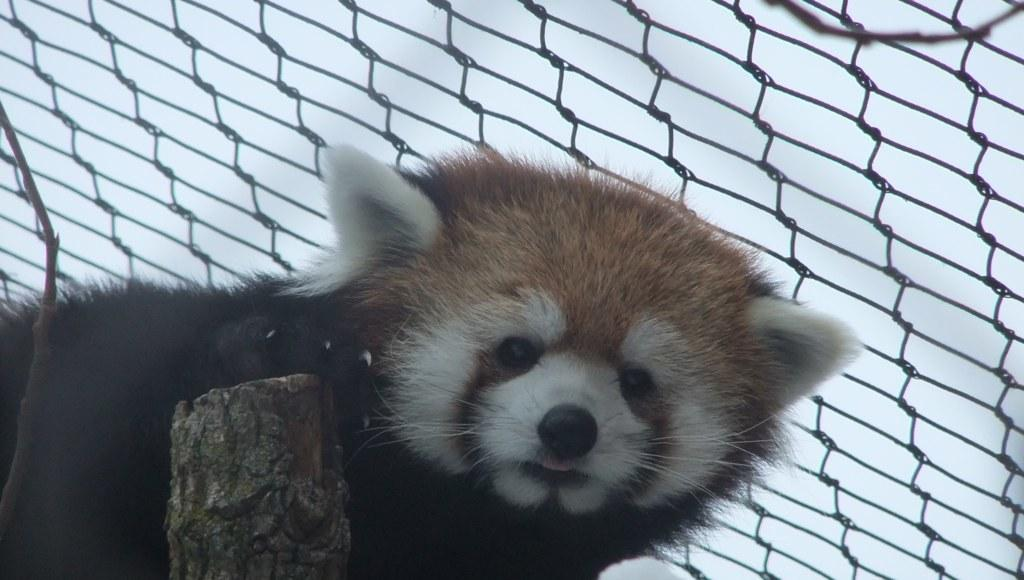What type of animal is in the image? There is an animal in the image, but its specific type cannot be determined from the provided facts. Can you describe the coloring of the animal? The animal has brown, white, and black coloring. What other objects are visible in the image? There is a wooden log and a net in the background of the image. What can be seen in the sky in the background of the image? The sky is visible in the background of the image. How does the animal use the plough in the image? There is no plough present in the image, so the animal cannot use it. What is the animal doing to get the attention of the viewer in the image? The animal's actions cannot be determined from the provided facts, so it is not possible to answer this question. 